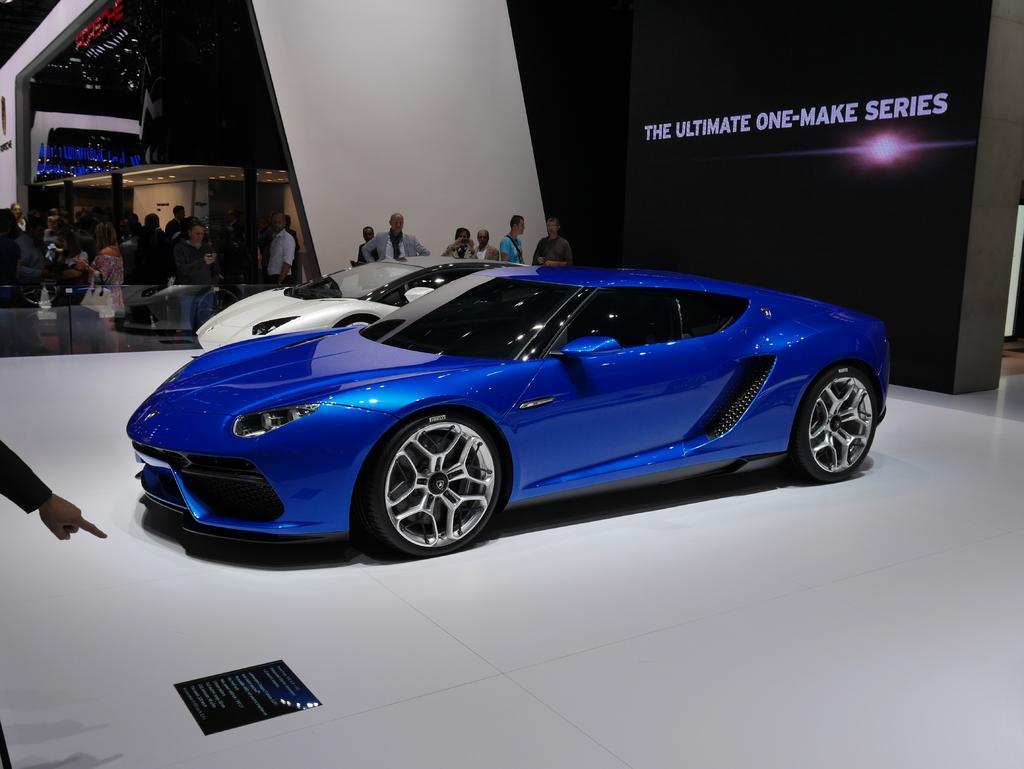Could you give a brief overview of what you see in this image? In this image there are cars on a floor, in the background there are people standing and there is an architecture and there is a board, on that board there is text. 